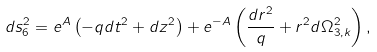<formula> <loc_0><loc_0><loc_500><loc_500>d s _ { 6 } ^ { 2 } = e ^ { A } \left ( - q d t ^ { 2 } + d z ^ { 2 } \right ) + e ^ { - A } \left ( \frac { d r ^ { 2 } } { q } + r ^ { 2 } d \Omega _ { 3 , k } ^ { 2 } \right ) ,</formula> 